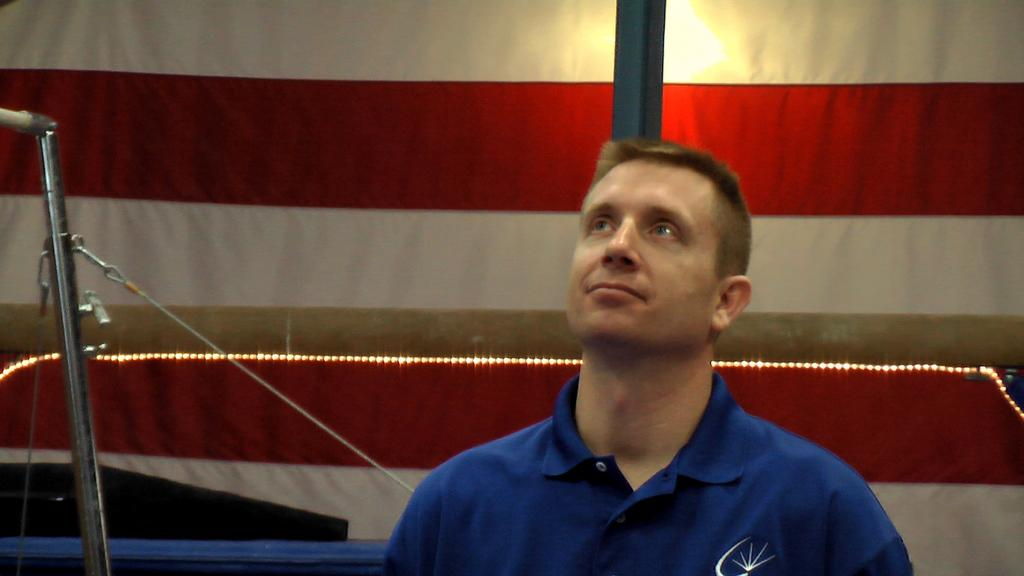Who or what is present in the image? There is a person in the image. What is the person interacting with in the image? The person is interacting with a gymnastic beam in the image. What can be seen on the left side of the image? There are objects on the left side of the image. What type of lighting is present in the image? There is a lamp in the image. Can you see a tent in the image? No, there is no tent present in the image. What type of base is supporting the gymnastic beam in the image? The provided facts do not mention a base for the gymnastic beam, so we cannot determine its support structure from the image. 